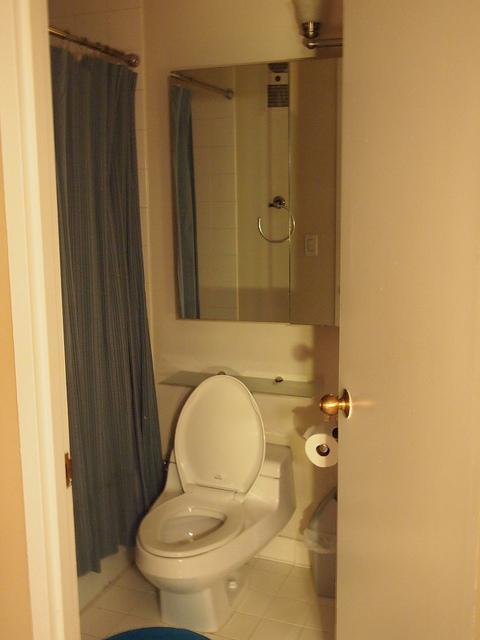Where would the toilet be?
Write a very short answer. Bathroom. What is the silver item that is seen in the mirror?
Quick response, please. Towel ring. What color is the toilet?
Give a very brief answer. White. Is the toilet seat open?
Write a very short answer. Yes. What shape is on the shower curtain?
Keep it brief. None. What is on the floor in front of the toilet?
Short answer required. Rug. Is the toilet seat up or down?
Concise answer only. Up. 